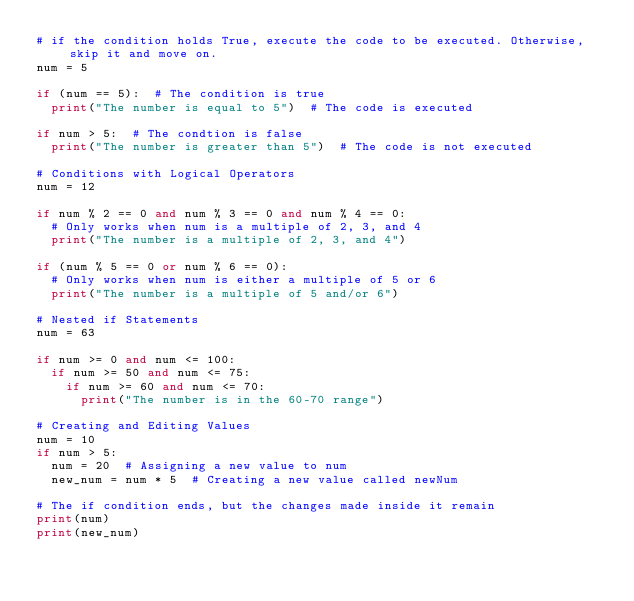<code> <loc_0><loc_0><loc_500><loc_500><_Python_># if the condition holds True, execute the code to be executed. Otherwise, skip it and move on.
num = 5

if (num == 5):  # The condition is true
  print("The number is equal to 5")  # The code is executed

if num > 5:  # The condtion is false
  print("The number is greater than 5")  # The code is not executed

# Conditions with Logical Operators
num = 12

if num % 2 == 0 and num % 3 == 0 and num % 4 == 0:
  # Only works when num is a multiple of 2, 3, and 4
  print("The number is a multiple of 2, 3, and 4")

if (num % 5 == 0 or num % 6 == 0):
  # Only works when num is either a multiple of 5 or 6
  print("The number is a multiple of 5 and/or 6")

# Nested if Statements
num = 63

if num >= 0 and num <= 100:
  if num >= 50 and num <= 75:
    if num >= 60 and num <= 70:
      print("The number is in the 60-70 range")

# Creating and Editing Values
num = 10
if num > 5:
  num = 20  # Assigning a new value to num
  new_num = num * 5  # Creating a new value called newNum

# The if condition ends, but the changes made inside it remain
print(num)
print(new_num)
</code> 